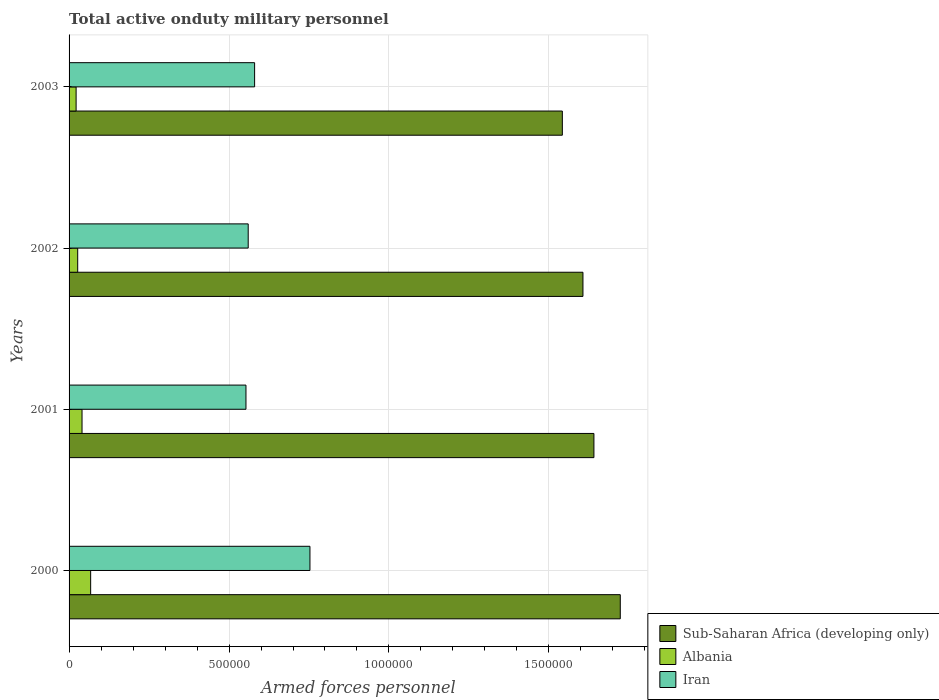How many different coloured bars are there?
Provide a short and direct response. 3. How many bars are there on the 4th tick from the top?
Ensure brevity in your answer.  3. In how many cases, is the number of bars for a given year not equal to the number of legend labels?
Make the answer very short. 0. What is the number of armed forces personnel in Iran in 2000?
Provide a short and direct response. 7.53e+05. Across all years, what is the maximum number of armed forces personnel in Albania?
Your answer should be very brief. 6.75e+04. Across all years, what is the minimum number of armed forces personnel in Iran?
Ensure brevity in your answer.  5.53e+05. What is the total number of armed forces personnel in Albania in the graph?
Your answer should be compact. 1.57e+05. What is the difference between the number of armed forces personnel in Iran in 2002 and that in 2003?
Provide a succinct answer. -2.00e+04. What is the difference between the number of armed forces personnel in Sub-Saharan Africa (developing only) in 2001 and the number of armed forces personnel in Albania in 2003?
Your answer should be very brief. 1.62e+06. What is the average number of armed forces personnel in Sub-Saharan Africa (developing only) per year?
Provide a short and direct response. 1.63e+06. In the year 2002, what is the difference between the number of armed forces personnel in Iran and number of armed forces personnel in Albania?
Ensure brevity in your answer.  5.33e+05. In how many years, is the number of armed forces personnel in Albania greater than 1300000 ?
Make the answer very short. 0. Is the difference between the number of armed forces personnel in Iran in 2001 and 2003 greater than the difference between the number of armed forces personnel in Albania in 2001 and 2003?
Your response must be concise. No. What is the difference between the highest and the second highest number of armed forces personnel in Sub-Saharan Africa (developing only)?
Keep it short and to the point. 8.24e+04. What is the difference between the highest and the lowest number of armed forces personnel in Albania?
Make the answer very short. 4.55e+04. What does the 1st bar from the top in 2001 represents?
Give a very brief answer. Iran. What does the 1st bar from the bottom in 2001 represents?
Give a very brief answer. Sub-Saharan Africa (developing only). How many bars are there?
Offer a very short reply. 12. Are all the bars in the graph horizontal?
Your response must be concise. Yes. Where does the legend appear in the graph?
Provide a succinct answer. Bottom right. What is the title of the graph?
Provide a short and direct response. Total active onduty military personnel. What is the label or title of the X-axis?
Your answer should be compact. Armed forces personnel. What is the Armed forces personnel in Sub-Saharan Africa (developing only) in 2000?
Keep it short and to the point. 1.72e+06. What is the Armed forces personnel in Albania in 2000?
Your response must be concise. 6.75e+04. What is the Armed forces personnel of Iran in 2000?
Keep it short and to the point. 7.53e+05. What is the Armed forces personnel of Sub-Saharan Africa (developing only) in 2001?
Provide a succinct answer. 1.64e+06. What is the Armed forces personnel in Albania in 2001?
Keep it short and to the point. 4.05e+04. What is the Armed forces personnel in Iran in 2001?
Offer a very short reply. 5.53e+05. What is the Armed forces personnel in Sub-Saharan Africa (developing only) in 2002?
Offer a terse response. 1.61e+06. What is the Armed forces personnel of Albania in 2002?
Ensure brevity in your answer.  2.70e+04. What is the Armed forces personnel in Iran in 2002?
Offer a very short reply. 5.60e+05. What is the Armed forces personnel in Sub-Saharan Africa (developing only) in 2003?
Offer a terse response. 1.54e+06. What is the Armed forces personnel in Albania in 2003?
Offer a terse response. 2.20e+04. What is the Armed forces personnel in Iran in 2003?
Your answer should be very brief. 5.80e+05. Across all years, what is the maximum Armed forces personnel in Sub-Saharan Africa (developing only)?
Offer a terse response. 1.72e+06. Across all years, what is the maximum Armed forces personnel of Albania?
Your answer should be very brief. 6.75e+04. Across all years, what is the maximum Armed forces personnel of Iran?
Provide a short and direct response. 7.53e+05. Across all years, what is the minimum Armed forces personnel of Sub-Saharan Africa (developing only)?
Provide a short and direct response. 1.54e+06. Across all years, what is the minimum Armed forces personnel of Albania?
Provide a short and direct response. 2.20e+04. Across all years, what is the minimum Armed forces personnel of Iran?
Your answer should be compact. 5.53e+05. What is the total Armed forces personnel in Sub-Saharan Africa (developing only) in the graph?
Keep it short and to the point. 6.51e+06. What is the total Armed forces personnel of Albania in the graph?
Make the answer very short. 1.57e+05. What is the total Armed forces personnel in Iran in the graph?
Your answer should be compact. 2.45e+06. What is the difference between the Armed forces personnel of Sub-Saharan Africa (developing only) in 2000 and that in 2001?
Give a very brief answer. 8.24e+04. What is the difference between the Armed forces personnel of Albania in 2000 and that in 2001?
Your answer should be very brief. 2.70e+04. What is the difference between the Armed forces personnel of Iran in 2000 and that in 2001?
Your response must be concise. 2.00e+05. What is the difference between the Armed forces personnel of Sub-Saharan Africa (developing only) in 2000 and that in 2002?
Ensure brevity in your answer.  1.17e+05. What is the difference between the Armed forces personnel in Albania in 2000 and that in 2002?
Keep it short and to the point. 4.05e+04. What is the difference between the Armed forces personnel in Iran in 2000 and that in 2002?
Give a very brief answer. 1.93e+05. What is the difference between the Armed forces personnel in Sub-Saharan Africa (developing only) in 2000 and that in 2003?
Offer a terse response. 1.81e+05. What is the difference between the Armed forces personnel in Albania in 2000 and that in 2003?
Make the answer very short. 4.55e+04. What is the difference between the Armed forces personnel of Iran in 2000 and that in 2003?
Make the answer very short. 1.73e+05. What is the difference between the Armed forces personnel of Sub-Saharan Africa (developing only) in 2001 and that in 2002?
Provide a short and direct response. 3.42e+04. What is the difference between the Armed forces personnel in Albania in 2001 and that in 2002?
Offer a very short reply. 1.35e+04. What is the difference between the Armed forces personnel in Iran in 2001 and that in 2002?
Ensure brevity in your answer.  -7000. What is the difference between the Armed forces personnel in Sub-Saharan Africa (developing only) in 2001 and that in 2003?
Offer a very short reply. 9.87e+04. What is the difference between the Armed forces personnel in Albania in 2001 and that in 2003?
Your answer should be very brief. 1.85e+04. What is the difference between the Armed forces personnel of Iran in 2001 and that in 2003?
Keep it short and to the point. -2.70e+04. What is the difference between the Armed forces personnel in Sub-Saharan Africa (developing only) in 2002 and that in 2003?
Keep it short and to the point. 6.44e+04. What is the difference between the Armed forces personnel of Sub-Saharan Africa (developing only) in 2000 and the Armed forces personnel of Albania in 2001?
Make the answer very short. 1.68e+06. What is the difference between the Armed forces personnel in Sub-Saharan Africa (developing only) in 2000 and the Armed forces personnel in Iran in 2001?
Provide a short and direct response. 1.17e+06. What is the difference between the Armed forces personnel of Albania in 2000 and the Armed forces personnel of Iran in 2001?
Make the answer very short. -4.86e+05. What is the difference between the Armed forces personnel of Sub-Saharan Africa (developing only) in 2000 and the Armed forces personnel of Albania in 2002?
Offer a very short reply. 1.70e+06. What is the difference between the Armed forces personnel in Sub-Saharan Africa (developing only) in 2000 and the Armed forces personnel in Iran in 2002?
Give a very brief answer. 1.16e+06. What is the difference between the Armed forces personnel in Albania in 2000 and the Armed forces personnel in Iran in 2002?
Your response must be concise. -4.92e+05. What is the difference between the Armed forces personnel in Sub-Saharan Africa (developing only) in 2000 and the Armed forces personnel in Albania in 2003?
Your answer should be very brief. 1.70e+06. What is the difference between the Armed forces personnel in Sub-Saharan Africa (developing only) in 2000 and the Armed forces personnel in Iran in 2003?
Ensure brevity in your answer.  1.14e+06. What is the difference between the Armed forces personnel in Albania in 2000 and the Armed forces personnel in Iran in 2003?
Ensure brevity in your answer.  -5.12e+05. What is the difference between the Armed forces personnel in Sub-Saharan Africa (developing only) in 2001 and the Armed forces personnel in Albania in 2002?
Provide a succinct answer. 1.61e+06. What is the difference between the Armed forces personnel in Sub-Saharan Africa (developing only) in 2001 and the Armed forces personnel in Iran in 2002?
Your answer should be compact. 1.08e+06. What is the difference between the Armed forces personnel in Albania in 2001 and the Armed forces personnel in Iran in 2002?
Give a very brief answer. -5.20e+05. What is the difference between the Armed forces personnel in Sub-Saharan Africa (developing only) in 2001 and the Armed forces personnel in Albania in 2003?
Provide a short and direct response. 1.62e+06. What is the difference between the Armed forces personnel in Sub-Saharan Africa (developing only) in 2001 and the Armed forces personnel in Iran in 2003?
Your response must be concise. 1.06e+06. What is the difference between the Armed forces personnel of Albania in 2001 and the Armed forces personnel of Iran in 2003?
Provide a succinct answer. -5.40e+05. What is the difference between the Armed forces personnel in Sub-Saharan Africa (developing only) in 2002 and the Armed forces personnel in Albania in 2003?
Provide a succinct answer. 1.58e+06. What is the difference between the Armed forces personnel of Sub-Saharan Africa (developing only) in 2002 and the Armed forces personnel of Iran in 2003?
Keep it short and to the point. 1.03e+06. What is the difference between the Armed forces personnel in Albania in 2002 and the Armed forces personnel in Iran in 2003?
Give a very brief answer. -5.53e+05. What is the average Armed forces personnel in Sub-Saharan Africa (developing only) per year?
Ensure brevity in your answer.  1.63e+06. What is the average Armed forces personnel in Albania per year?
Give a very brief answer. 3.92e+04. What is the average Armed forces personnel in Iran per year?
Your response must be concise. 6.12e+05. In the year 2000, what is the difference between the Armed forces personnel in Sub-Saharan Africa (developing only) and Armed forces personnel in Albania?
Your answer should be very brief. 1.66e+06. In the year 2000, what is the difference between the Armed forces personnel in Sub-Saharan Africa (developing only) and Armed forces personnel in Iran?
Provide a short and direct response. 9.70e+05. In the year 2000, what is the difference between the Armed forces personnel of Albania and Armed forces personnel of Iran?
Your response must be concise. -6.86e+05. In the year 2001, what is the difference between the Armed forces personnel in Sub-Saharan Africa (developing only) and Armed forces personnel in Albania?
Make the answer very short. 1.60e+06. In the year 2001, what is the difference between the Armed forces personnel in Sub-Saharan Africa (developing only) and Armed forces personnel in Iran?
Your answer should be very brief. 1.09e+06. In the year 2001, what is the difference between the Armed forces personnel in Albania and Armed forces personnel in Iran?
Make the answer very short. -5.12e+05. In the year 2002, what is the difference between the Armed forces personnel of Sub-Saharan Africa (developing only) and Armed forces personnel of Albania?
Provide a succinct answer. 1.58e+06. In the year 2002, what is the difference between the Armed forces personnel of Sub-Saharan Africa (developing only) and Armed forces personnel of Iran?
Offer a terse response. 1.05e+06. In the year 2002, what is the difference between the Armed forces personnel of Albania and Armed forces personnel of Iran?
Provide a succinct answer. -5.33e+05. In the year 2003, what is the difference between the Armed forces personnel in Sub-Saharan Africa (developing only) and Armed forces personnel in Albania?
Provide a succinct answer. 1.52e+06. In the year 2003, what is the difference between the Armed forces personnel in Sub-Saharan Africa (developing only) and Armed forces personnel in Iran?
Offer a terse response. 9.62e+05. In the year 2003, what is the difference between the Armed forces personnel of Albania and Armed forces personnel of Iran?
Provide a short and direct response. -5.58e+05. What is the ratio of the Armed forces personnel of Sub-Saharan Africa (developing only) in 2000 to that in 2001?
Your answer should be compact. 1.05. What is the ratio of the Armed forces personnel in Iran in 2000 to that in 2001?
Provide a succinct answer. 1.36. What is the ratio of the Armed forces personnel of Sub-Saharan Africa (developing only) in 2000 to that in 2002?
Keep it short and to the point. 1.07. What is the ratio of the Armed forces personnel in Albania in 2000 to that in 2002?
Offer a very short reply. 2.5. What is the ratio of the Armed forces personnel of Iran in 2000 to that in 2002?
Your answer should be very brief. 1.34. What is the ratio of the Armed forces personnel of Sub-Saharan Africa (developing only) in 2000 to that in 2003?
Provide a short and direct response. 1.12. What is the ratio of the Armed forces personnel in Albania in 2000 to that in 2003?
Provide a succinct answer. 3.07. What is the ratio of the Armed forces personnel in Iran in 2000 to that in 2003?
Your answer should be compact. 1.3. What is the ratio of the Armed forces personnel of Sub-Saharan Africa (developing only) in 2001 to that in 2002?
Your answer should be compact. 1.02. What is the ratio of the Armed forces personnel in Albania in 2001 to that in 2002?
Ensure brevity in your answer.  1.5. What is the ratio of the Armed forces personnel of Iran in 2001 to that in 2002?
Offer a very short reply. 0.99. What is the ratio of the Armed forces personnel in Sub-Saharan Africa (developing only) in 2001 to that in 2003?
Offer a terse response. 1.06. What is the ratio of the Armed forces personnel of Albania in 2001 to that in 2003?
Give a very brief answer. 1.84. What is the ratio of the Armed forces personnel in Iran in 2001 to that in 2003?
Your answer should be very brief. 0.95. What is the ratio of the Armed forces personnel in Sub-Saharan Africa (developing only) in 2002 to that in 2003?
Make the answer very short. 1.04. What is the ratio of the Armed forces personnel of Albania in 2002 to that in 2003?
Keep it short and to the point. 1.23. What is the ratio of the Armed forces personnel in Iran in 2002 to that in 2003?
Keep it short and to the point. 0.97. What is the difference between the highest and the second highest Armed forces personnel in Sub-Saharan Africa (developing only)?
Ensure brevity in your answer.  8.24e+04. What is the difference between the highest and the second highest Armed forces personnel in Albania?
Your answer should be very brief. 2.70e+04. What is the difference between the highest and the second highest Armed forces personnel in Iran?
Your response must be concise. 1.73e+05. What is the difference between the highest and the lowest Armed forces personnel of Sub-Saharan Africa (developing only)?
Your response must be concise. 1.81e+05. What is the difference between the highest and the lowest Armed forces personnel of Albania?
Make the answer very short. 4.55e+04. 